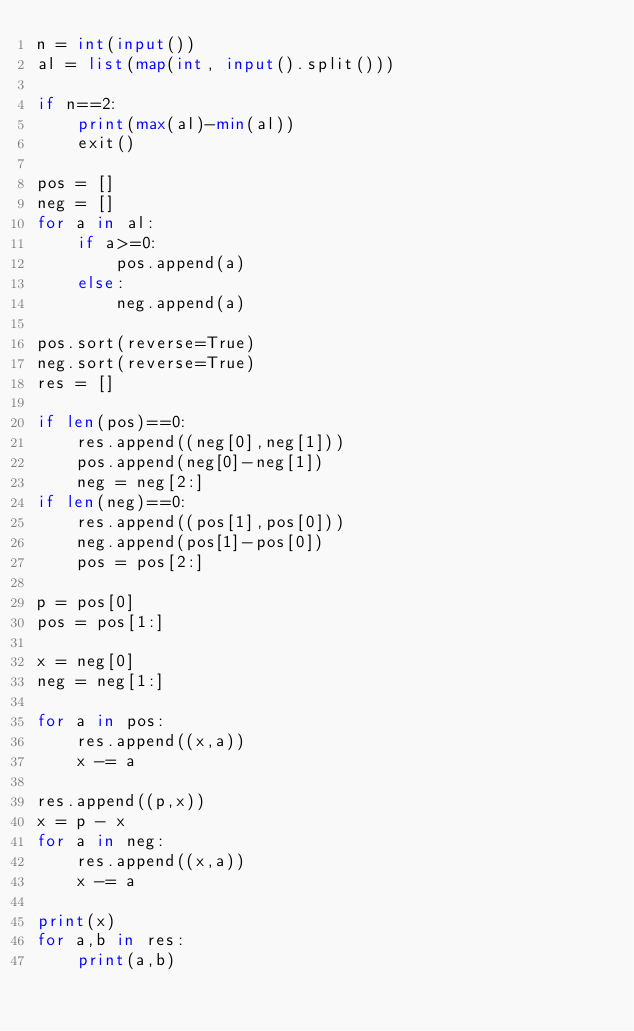Convert code to text. <code><loc_0><loc_0><loc_500><loc_500><_Python_>n = int(input())
al = list(map(int, input().split()))

if n==2:
    print(max(al)-min(al))
    exit()

pos = []
neg = []
for a in al:
    if a>=0:
        pos.append(a)
    else:
        neg.append(a)

pos.sort(reverse=True)
neg.sort(reverse=True)
res = []

if len(pos)==0:
    res.append((neg[0],neg[1]))
    pos.append(neg[0]-neg[1])
    neg = neg[2:]
if len(neg)==0:
    res.append((pos[1],pos[0]))
    neg.append(pos[1]-pos[0])
    pos = pos[2:]

p = pos[0]
pos = pos[1:]

x = neg[0]
neg = neg[1:]

for a in pos:
    res.append((x,a))
    x -= a

res.append((p,x))
x = p - x
for a in neg:
    res.append((x,a))
    x -= a

print(x)
for a,b in res:
    print(a,b)</code> 